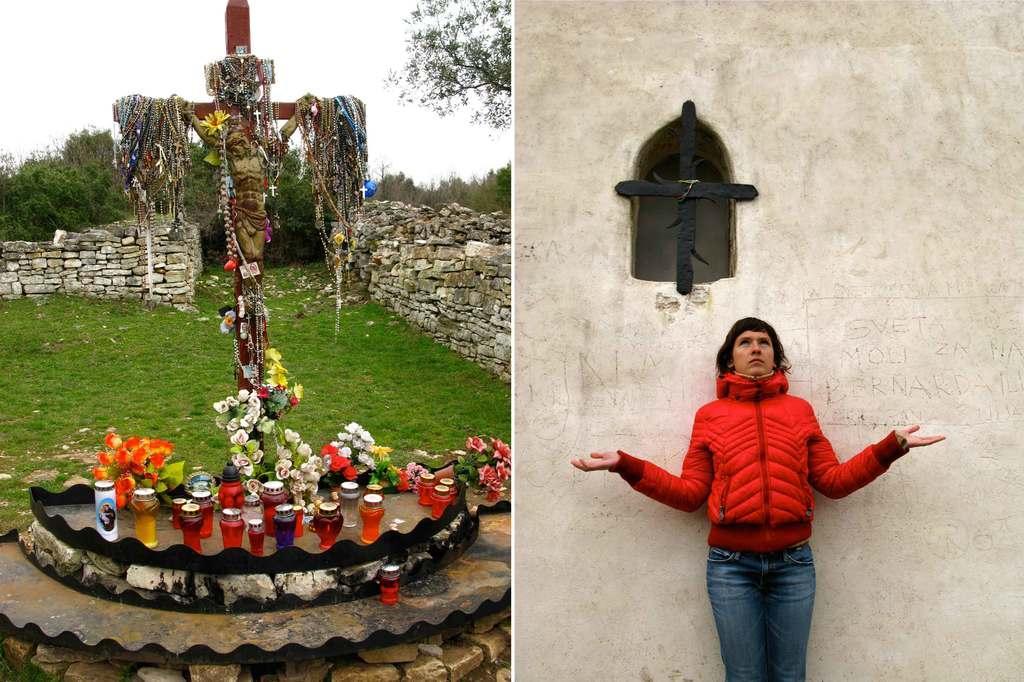How would you summarize this image in a sentence or two? This is a collage image of two pictures, one the left side there is a cross with jesus sculpture on it, also there are some other objects, behind them there is a wall and trees, on the right side there is a person standing in-front of the wall, at the top there is a cross symbol on the window hole. 